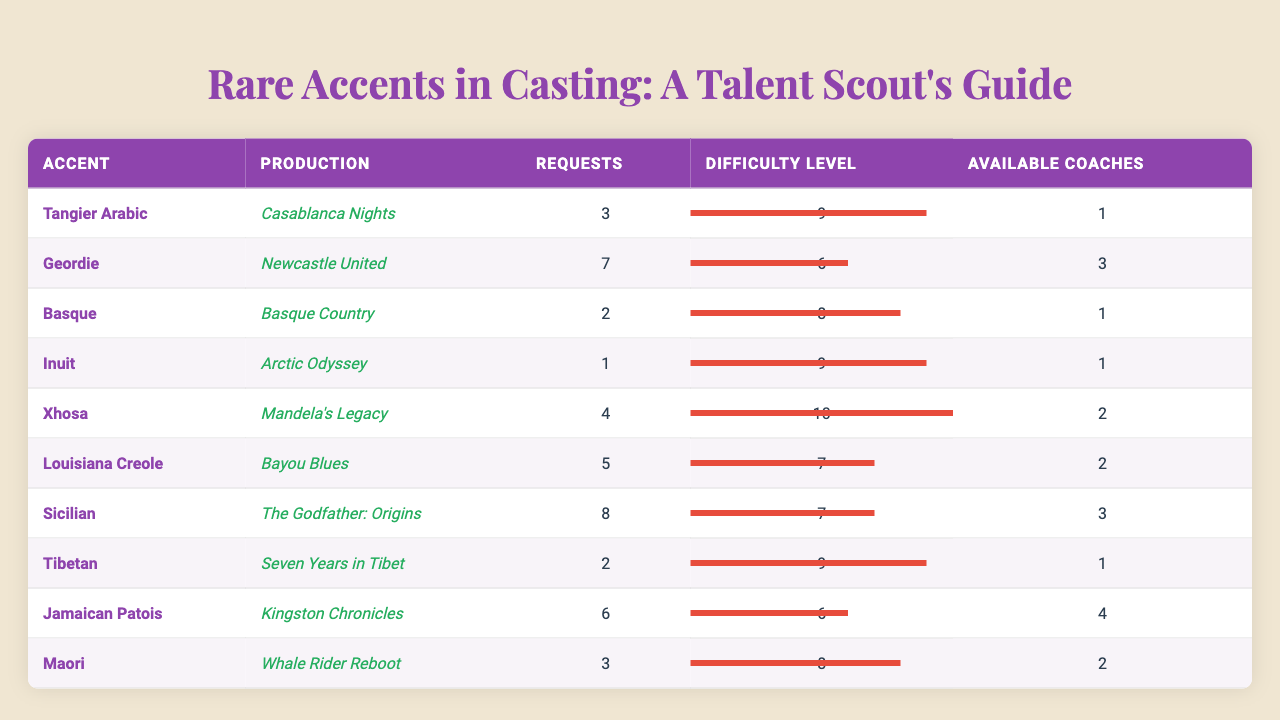What accent has the highest number of requests? By looking at the "Requests" column, the accent with the highest value is "Sicilian" with 8 requests.
Answer: Sicilian Which accent has the lowest difficulty level? The difficulty levels listed range from 6 to 10, where "Geordie" and "Kingston Chronicles" both have a difficulty level of 6, making them the lowest.
Answer: Geordie, Kingston Chronicles How many available coaches are there for "Jamaican Patois"? The "Available Coaches" column indicates there are 1 coach available for "Jamaican Patois."
Answer: 1 What is the average difficulty level of the accents listed? The sum of difficulty levels is (9 + 6 + 8 + 9 + 10 + 7 + 7 + 9 + 6 + 8) = 79. There are 10 accents, so the average is 79/10 = 7.9.
Answer: 7.9 Is there an accent with more requests than available coaches? Comparing the "Requests" and "Available Coaches" columns, "Louisiana Creole" has 5 requests and 2 available coaches, which confirms there is an accent with more requests than coaches.
Answer: Yes What is the total number of requests for the accents with a difficulty level of 9? The accents with a difficulty level of 9 are "Tangier Arabic," "Inuit," and "Kingston Chronicles," with requests totaling (3 + 1 + 6) = 10.
Answer: 10 Which production has the lowest number of requests and how many are there? By inspecting the "Requests" column, "Inuit" from "Arctic Odyssey" has the lowest number of requests with just 1.
Answer: 1 How many more accents are there with 5 or more requests than with less than 5 requests? Accents with 5 or more requests: "Geordie" (7), "Louisiana Creole" (5), "Sicilian" (8), and "Kingston Chronicles" (6) totals 4. Accents with less than 5 requests are "Basque" (2), "Inuit" (1), and "Tibetan" (2) total 3. Hence, there are 4 minus 3 equals 1 more accent with 5 or more requests.
Answer: 1 Which accent has the highest difficulty level and how many requests did it receive? "Mandela's Legacy" corresponds to "Xhosa," which has the highest difficulty level of 10 and received 4 requests.
Answer: Xhosa, 4 If a new accent appears with 7 requests and a difficulty level of 6, how many total requests would there be if we add it to the current total? The current total of requests is (3 + 7 + 2 + 1 + 4 + 5 + 8 + 2 + 6 + 3) = 41. Adding the new accent with 7 requests brings the total to 41 + 7 = 48.
Answer: 48 